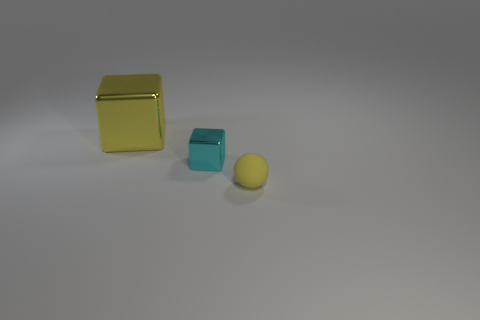There is a metal object in front of the large yellow metal block; is it the same size as the yellow thing that is left of the small sphere?
Your response must be concise. No. What number of things are either large green balls or tiny objects that are to the left of the tiny yellow rubber sphere?
Ensure brevity in your answer.  1. Is there another matte object of the same shape as the matte object?
Your response must be concise. No. How big is the yellow object in front of the object that is behind the tiny cube?
Your response must be concise. Small. Is the color of the tiny shiny cube the same as the large thing?
Offer a very short reply. No. How many matte objects are either big cubes or big purple balls?
Your answer should be compact. 0. How many tiny things are there?
Give a very brief answer. 2. Does the small object that is behind the tiny yellow sphere have the same material as the yellow object to the right of the large yellow object?
Offer a very short reply. No. There is a tiny metallic object that is the same shape as the big shiny object; what is its color?
Offer a terse response. Cyan. What is the material of the block that is right of the yellow thing that is left of the small yellow rubber sphere?
Your answer should be compact. Metal. 